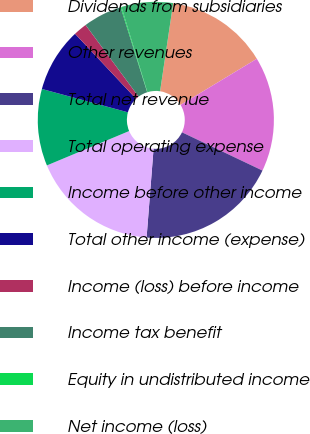Convert chart. <chart><loc_0><loc_0><loc_500><loc_500><pie_chart><fcel>Dividends from subsidiaries<fcel>Other revenues<fcel>Total net revenue<fcel>Total operating expense<fcel>Income before other income<fcel>Total other income (expense)<fcel>Income (loss) before income<fcel>Income tax benefit<fcel>Equity in undistributed income<fcel>Net income (loss)<nl><fcel>13.99%<fcel>15.72%<fcel>19.19%<fcel>17.45%<fcel>10.52%<fcel>8.79%<fcel>1.85%<fcel>5.32%<fcel>0.12%<fcel>7.05%<nl></chart> 